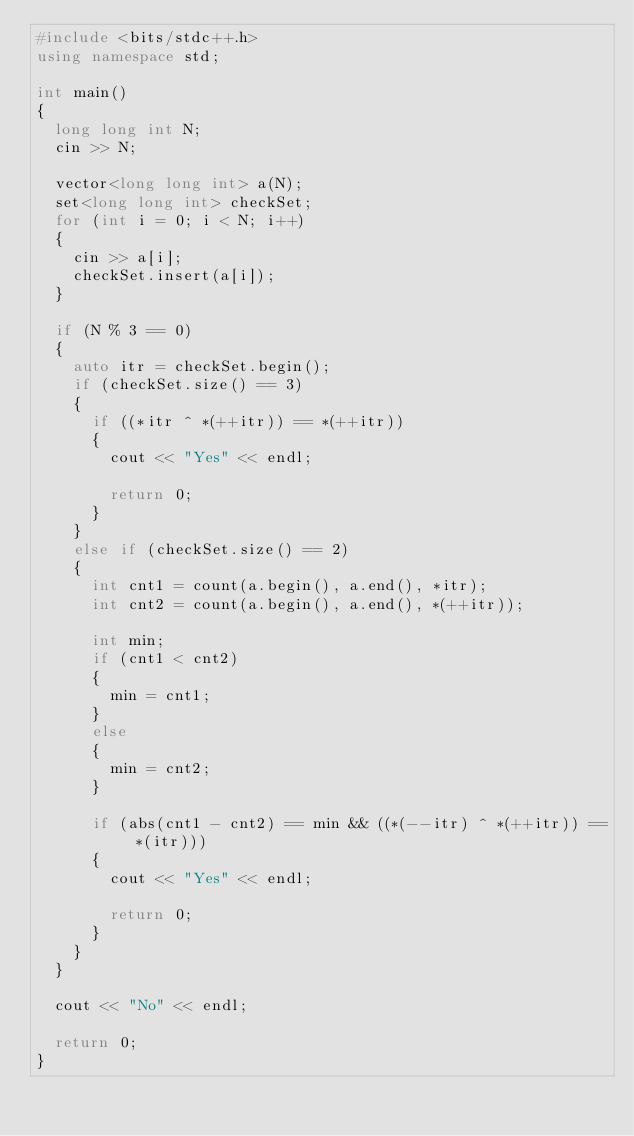Convert code to text. <code><loc_0><loc_0><loc_500><loc_500><_C++_>#include <bits/stdc++.h>
using namespace std;

int main()
{
	long long int N;
	cin >> N;

	vector<long long int> a(N);
	set<long long int> checkSet;
	for (int i = 0; i < N; i++)
	{
		cin >> a[i];
		checkSet.insert(a[i]);
	}

	if (N % 3 == 0)
	{
		auto itr = checkSet.begin();
		if (checkSet.size() == 3)
		{
			if ((*itr ^ *(++itr)) == *(++itr))
			{
				cout << "Yes" << endl;

				return 0;
			}
		}
		else if (checkSet.size() == 2)
		{
			int cnt1 = count(a.begin(), a.end(), *itr);
			int cnt2 = count(a.begin(), a.end(), *(++itr));

			int min;
			if (cnt1 < cnt2)
			{
				min = cnt1;
			}
			else
			{
				min = cnt2;
			}

			if (abs(cnt1 - cnt2) == min && ((*(--itr) ^ *(++itr)) == *(itr)))
			{
				cout << "Yes" << endl;

				return 0;
			}
		}
	}

	cout << "No" << endl;

	return 0;
}
</code> 